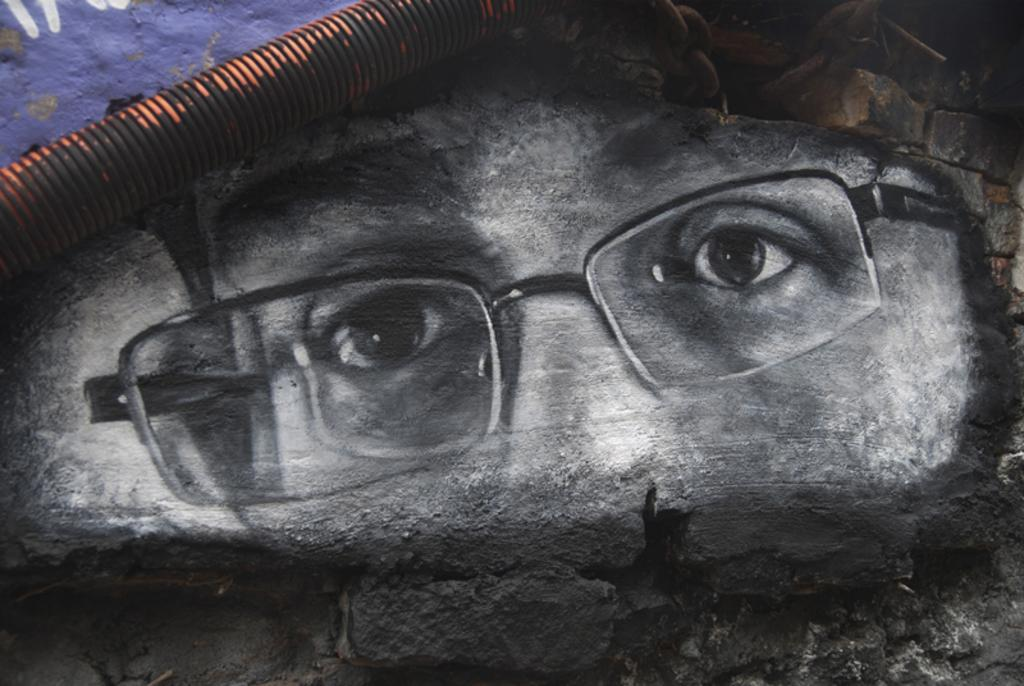What is the main subject of the wall painting in the image? The wall painting depicts a person's face with glasses. Can you describe any other details about the painting? There are no other details mentioned in the provided facts. What else can be seen in the image besides the wall painting? There is a pipe visible in the image. What type of wound is visible on the person's face in the image? There is no wound visible on the person's face in the image; the painting depicts a person's face with glasses. What kind of operation is being performed on the person in the image? There is no operation being performed on the person in the image; it is a wall painting of a person's face with glasses. 